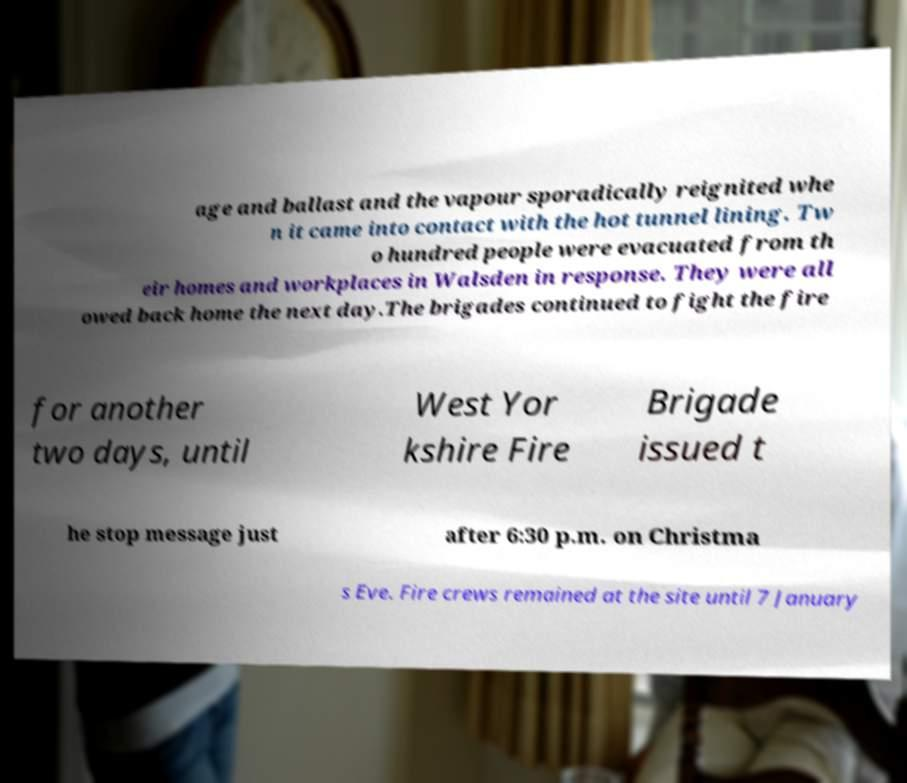Please identify and transcribe the text found in this image. age and ballast and the vapour sporadically reignited whe n it came into contact with the hot tunnel lining. Tw o hundred people were evacuated from th eir homes and workplaces in Walsden in response. They were all owed back home the next day.The brigades continued to fight the fire for another two days, until West Yor kshire Fire Brigade issued t he stop message just after 6:30 p.m. on Christma s Eve. Fire crews remained at the site until 7 January 